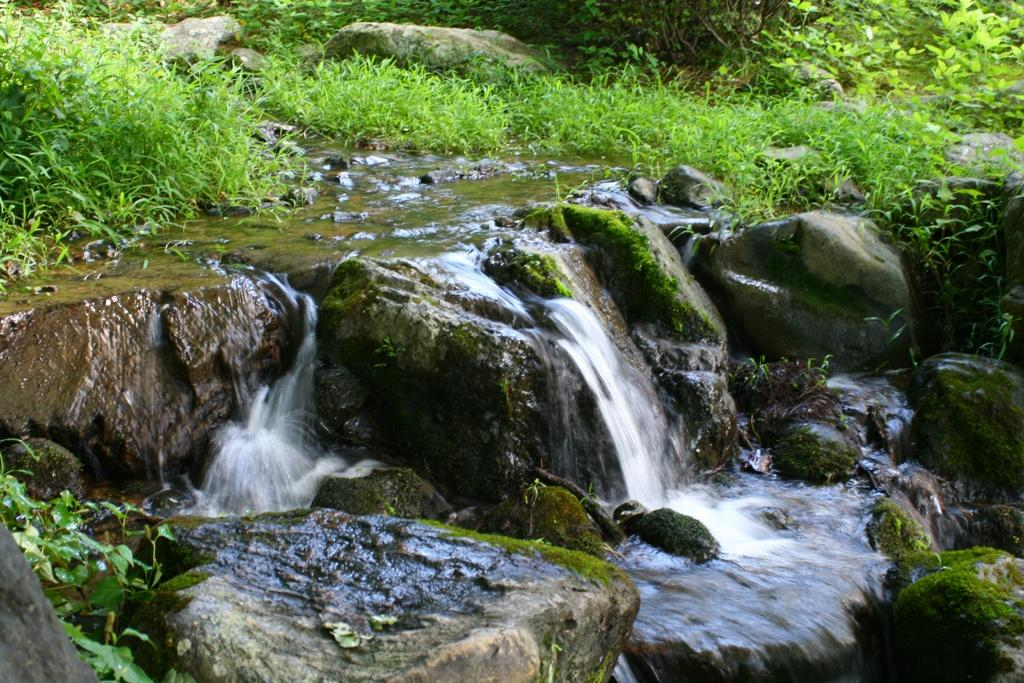What natural feature can be seen in the image? There is a small waterfall in the image. What type of vegetation is present in the image? There are plants in the image. What type of geological formation can be seen in the image? Rocks are present in the image. What decision does the waterfall make in the image? The waterfall does not make decisions in the image; it is a natural feature that flows downward due to gravity. 